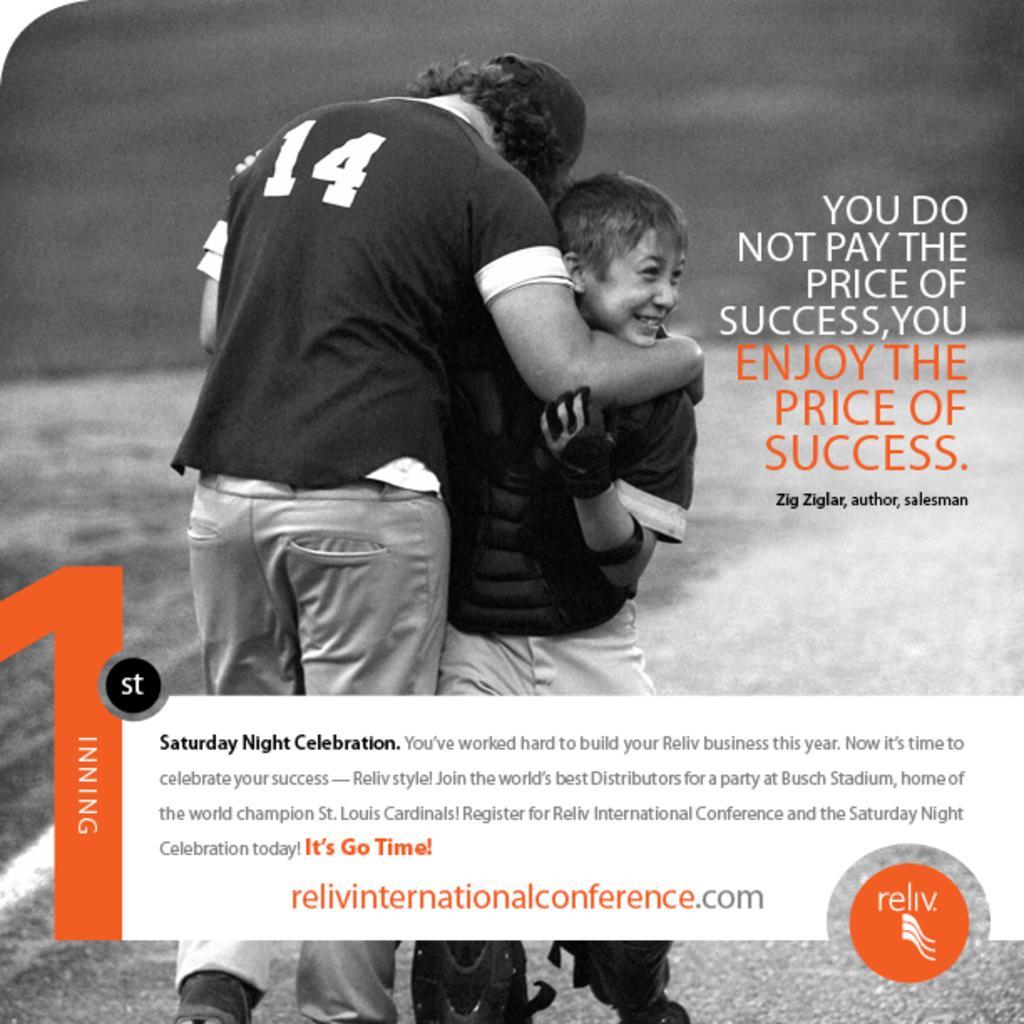In one or two sentences, can you explain what this image depicts? This is a black and white picture, in this image we can see a poster with two persons and some text on it. 